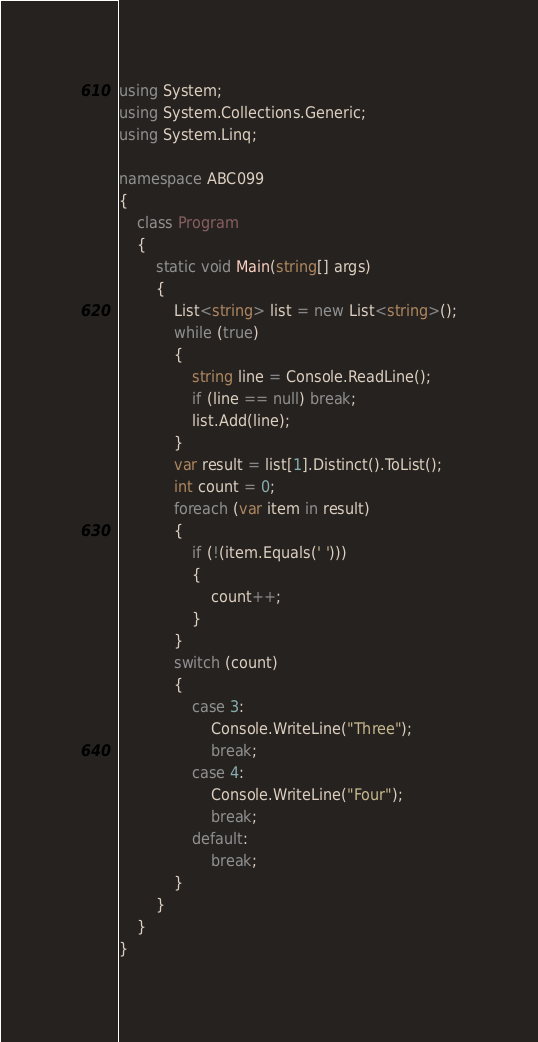<code> <loc_0><loc_0><loc_500><loc_500><_C#_>using System;
using System.Collections.Generic;
using System.Linq;

namespace ABC099
{
    class Program
    {
        static void Main(string[] args)
        {
            List<string> list = new List<string>();
            while (true)
            {
                string line = Console.ReadLine();
                if (line == null) break;
                list.Add(line);
            }
            var result = list[1].Distinct().ToList();
            int count = 0;
            foreach (var item in result)
            {
                if (!(item.Equals(' ')))
                {
                    count++;
                }
            }
            switch (count)
            {
                case 3:
                    Console.WriteLine("Three");
                    break;
                case 4:
                    Console.WriteLine("Four");
                    break;
                default:
                    break;
            }
        }
    }
}
</code> 